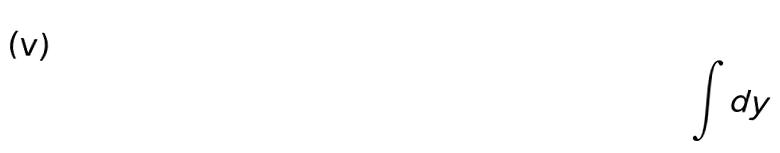Convert formula to latex. <formula><loc_0><loc_0><loc_500><loc_500>\int d y</formula> 